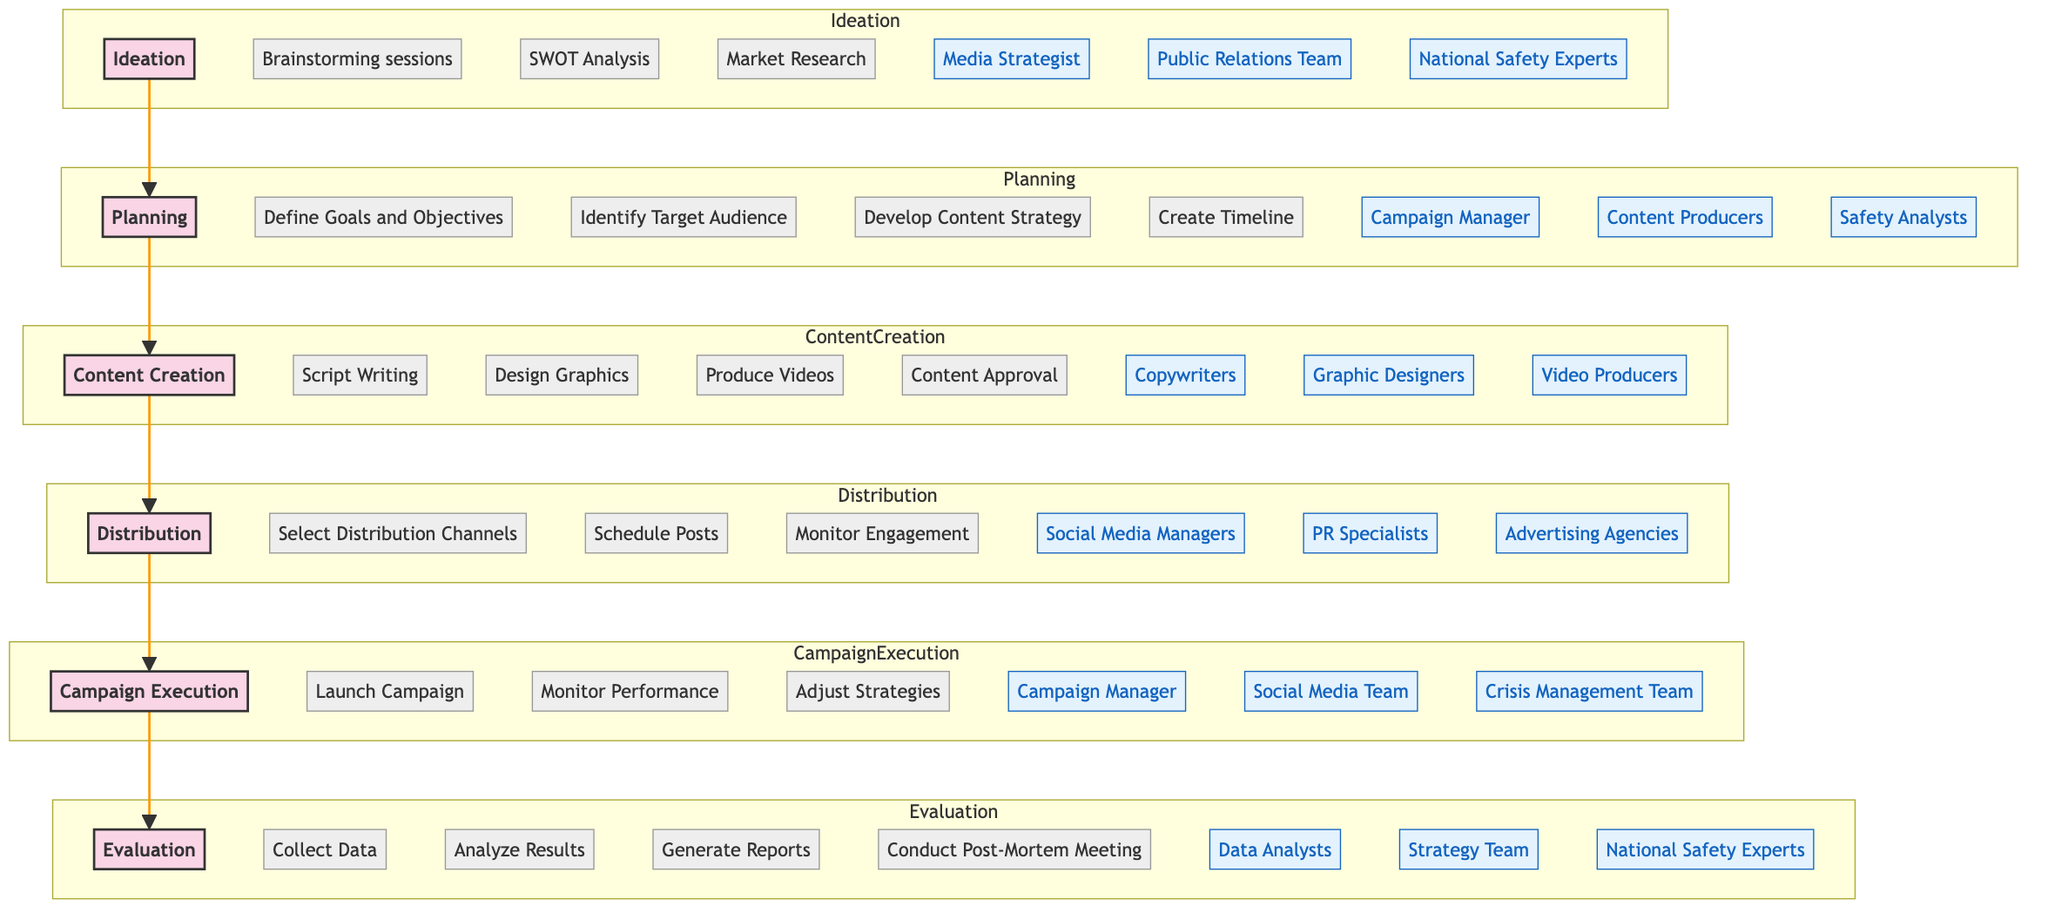what is the primary objective of the Evaluation stage? The Evaluation stage's primary objective is explicitly listed in the diagram as "Evaluate the effectiveness of the campaign." Therefore, by locating the Evaluation stage and reading the step details, the answer is obtained.
Answer: Evaluate the effectiveness of the campaign who are the key stakeholders involved in the Content Creation stage? The key stakeholders for Content Creation are listed in the diagram as Copywriters, Graphic Designers, and Video Producers. By identifying the stakeholders within the Content Creation subgraph, these roles can be compiled to answer the question.
Answer: Copywriters, Graphic Designers, Video Producers how many activities are there in the Planning stage? The Planning stage consists of four activities mentioned in the diagram: Define Goals and Objectives, Identify Target Audience, Develop Content Strategy, and Create Timeline. Counting these activities provides the numerical answer to the question.
Answer: 4 which stage comes after Distribution in the Media Campaign Lifecycle? The diagram shows the flow of the Media Campaign Lifecycle stages. After Distribution, the next stage indicated in the sequence is Campaign Execution. Thus, tracing the flow from Distribution leads directly to the answer.
Answer: Campaign Execution what are the activities listed under the Distribution stage? In the diagram, the activities for the Distribution stage are: Select Distribution Channels, Schedule Posts, and Monitor Engagement. These activities are explicitly listed and can be gathered directly to form the answer.
Answer: Select Distribution Channels, Schedule Posts, Monitor Engagement who leads the Planning stage as a key stakeholder? The diagram identifies the Campaign Manager as a key stakeholder for the Planning stage. By looking at the Planning subgraph, this individual is distinctly noted as part of the planning team.
Answer: Campaign Manager how many stages are there in the Media Campaign Lifecycle? The diagram outlines a total of six stages, which are Ideation, Planning, Content Creation, Distribution, Campaign Execution, and Evaluation. Counting these stages provides a quick numerical response to the question.
Answer: 6 which activity in the Campaign Execution stage involves monitoring and strategy adjustment? The activities listed in the Campaign Execution stage include Launch Campaign, Monitor Performance, and Adjust Strategies. Among these, 'Monitor Performance' and 'Adjust Strategies' specifically refer to monitoring and making strategic adjustments. Thus, this activity can be directly referenced from the diagram.
Answer: Monitor Performance, Adjust Strategies 